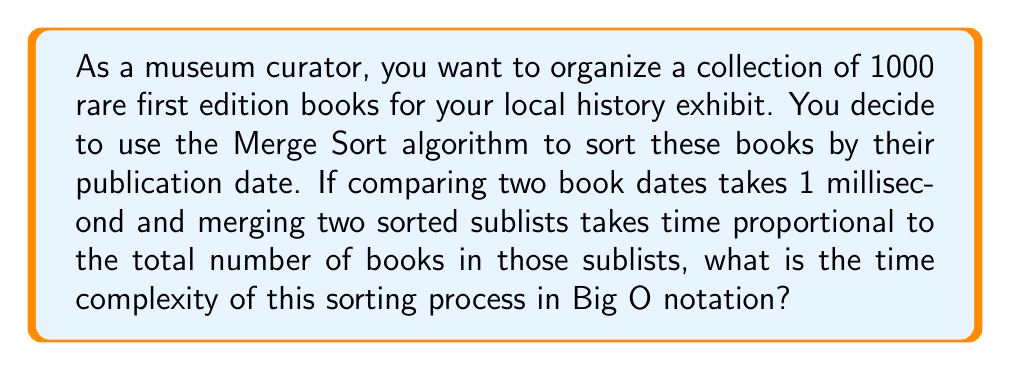Show me your answer to this math problem. Let's analyze the Merge Sort algorithm step by step:

1) Merge Sort is a divide-and-conquer algorithm that recursively divides the input array into two halves, sorts them, and then merges them.

2) The algorithm can be broken down into two main operations:
   a) Dividing the array
   b) Merging the sorted subarrays

3) Let $n$ be the number of books (1000 in this case).

4) The division process creates a recursion tree with $\log_2 n$ levels, as the array is divided in half at each step until we reach single elements.

5) At each level of the recursion tree, we perform merging operations. The total number of comparisons at each level is proportional to $n$, as each book is compared once per level.

6) Given that each comparison takes 1 millisecond, the time for comparisons at each level is $O(n)$.

7) The merging process at each level also takes time proportional to $n$, as stated in the question.

8) Therefore, at each level, we perform $O(n)$ operations.

9) Since there are $\log_2 n$ levels, the total time complexity is:

   $$O(n \log n)$$

10) This is the standard time complexity for Merge Sort, which remains true even with the additional merging time, as it's still proportional to $n$ at each level.

While the actual running time will depend on the constant factors involved (like the 1 millisecond per comparison), the Big O notation describes the growth rate of the algorithm's running time as the input size increases.
Answer: $O(n \log n)$ 